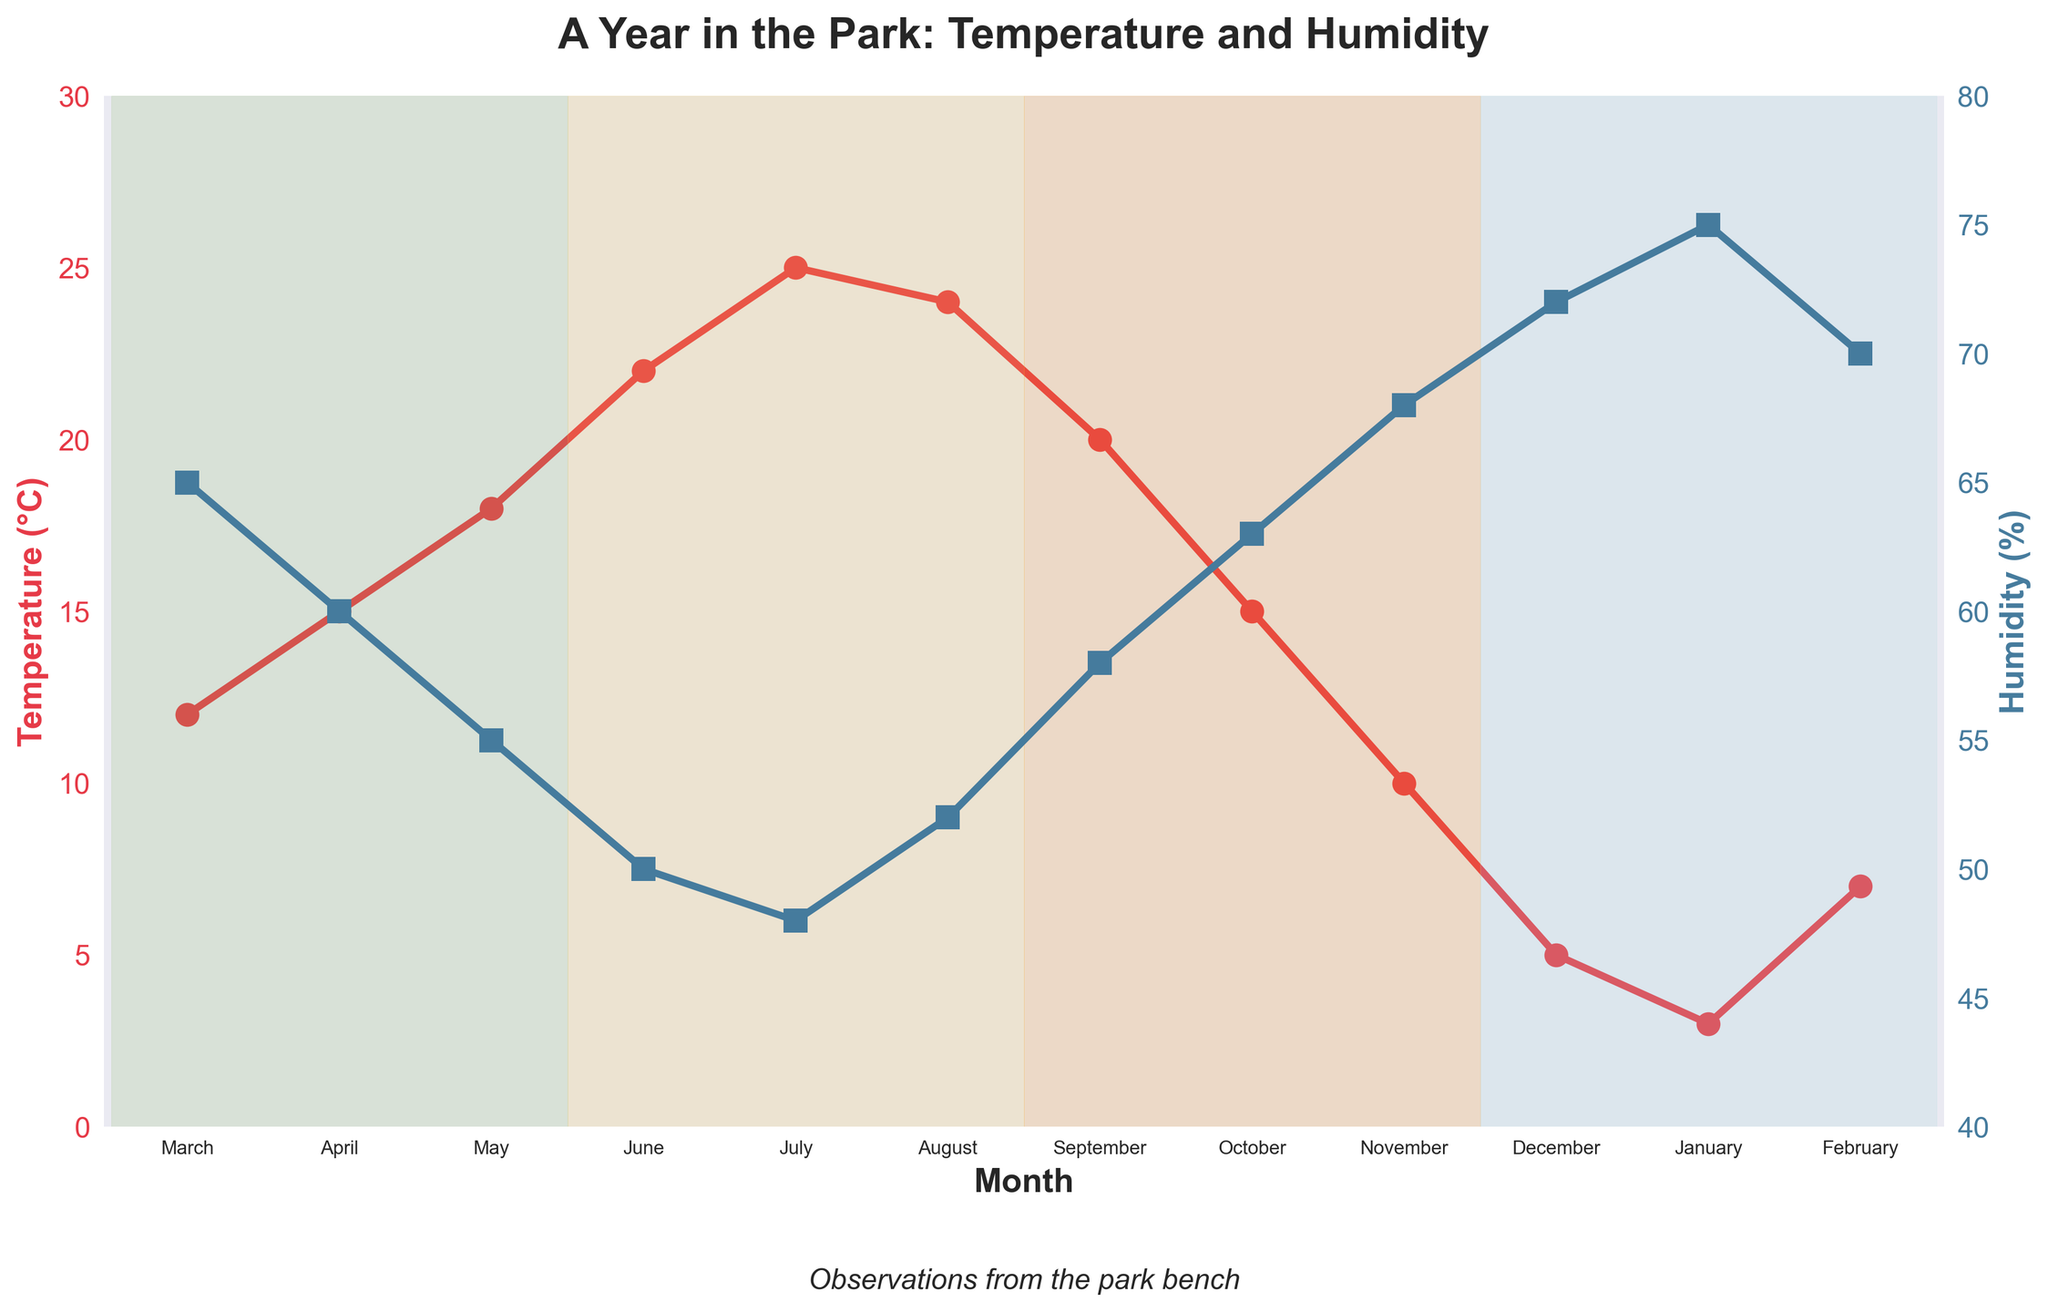What is the average temperature in April? The plot shows a red line for temperature with markers at each month. Looking at April, we see the marker's height.
Answer: 15°C Which month has the highest average humidity? The plot shows a blue line for humidity with markers at each month. The highest marker corresponds to January.
Answer: January How does the average temperature in April compare to that in October? By comparing the heights of the red markers for April and October, both are at the same height, indicating equal temperatures.
Answer: They are equal What's the difference in average humidity between July and November? The blue marker for July is at 48%, and for November, it is at 68%. The difference is 68% - 48% = 20%.
Answer: 20% Which season has the lowest average temperature and what is it? The plot shows temperature variations across seasons. The winter months (December, January, February) have the lowest values. The marker for January shows the lowest temperature.
Answer: Winter - 3°C In which month do we see the highest spread between temperature and humidity levels? Observing the plot, July has a significant spread with a high temperature (red marker) and low humidity (blue marker).
Answer: July Compare the average humidity levels in summer and winter. Which season is more humid? The blue markers in winter (December, January, February) are higher than in summer (June, July, August), indicating higher humidity levels in winter.
Answer: Winter What is the average temperature across the summer months? Summing the temperatures for June, July, and August: 22 + 25 + 24 = 71, then dividing by 3 gives 71/3 ≈ 23.67.
Answer: 23.67°C By how many degrees does the average temperature decrease from September to December? September's temperature is 20°C, December's is 5°C. The difference is 20 - 5 = 15°C.
Answer: 15°C What month's average temperature is closest to the annual average temperature? Calculate the total annual temperature sum: 12 + 15 + 18 + 22 + 25 + 24 + 20 + 15 + 10 + 5 + 3 + 7 = 176. The average annual temperature is 176 / 12 ≈ 14.67°C. The closest monthly temperature is 15°C (April and October).
Answer: April and October 